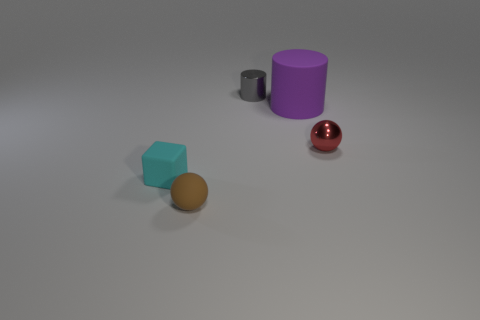Are there fewer red shiny things than things?
Your answer should be compact. Yes. There is a shiny thing behind the cylinder in front of the cylinder that is behind the big purple cylinder; what shape is it?
Give a very brief answer. Cylinder. Is there another cylinder that has the same material as the large cylinder?
Make the answer very short. No. Are there fewer large purple cylinders to the left of the small cylinder than tiny metallic spheres?
Offer a very short reply. Yes. What number of things are small brown balls or objects that are behind the small brown rubber ball?
Give a very brief answer. 5. What color is the tiny object that is the same material as the small cyan cube?
Your answer should be compact. Brown. What number of objects are large blue matte spheres or matte things?
Your answer should be very brief. 3. There is a block that is the same size as the metallic cylinder; what color is it?
Provide a short and direct response. Cyan. How many objects are balls that are on the left side of the gray shiny object or tiny gray metal objects?
Give a very brief answer. 2. How many other things are there of the same size as the red thing?
Give a very brief answer. 3. 